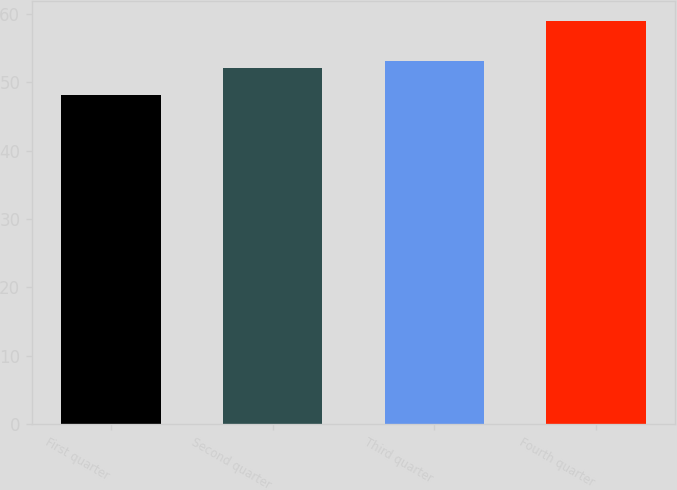<chart> <loc_0><loc_0><loc_500><loc_500><bar_chart><fcel>First quarter<fcel>Second quarter<fcel>Third quarter<fcel>Fourth quarter<nl><fcel>48.1<fcel>52.02<fcel>53.1<fcel>58.9<nl></chart> 